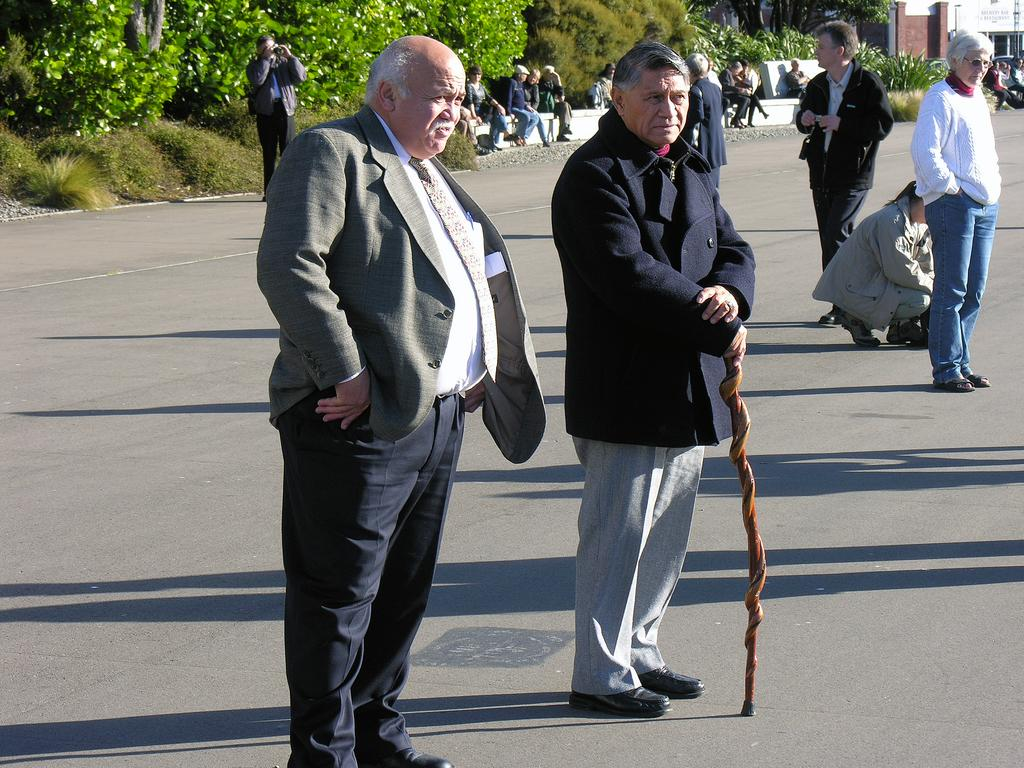What is happening on the road in the image? There are persons on the road in the image. What is one of the persons holding? One of the persons is holding a stick. Can you describe the background of the image? There are persons sitting, trees, plants, and a building in the background of the image. How many ducks are sitting on the building in the image? There are no ducks present in the image; it features persons on the road, a person holding a stick, and a background with persons sitting, trees, plants, and a building. What type of crime is being committed in the image? There is no indication of any crime being committed in the image. 